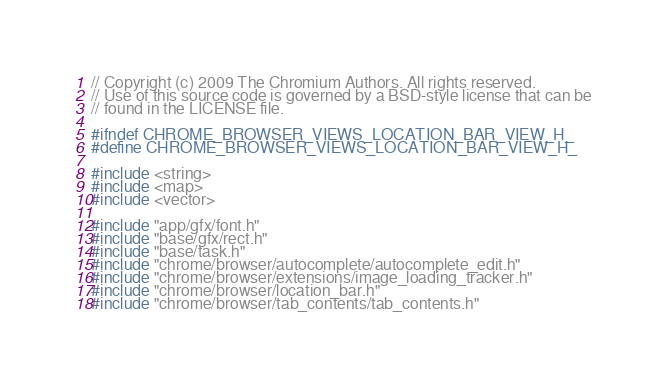Convert code to text. <code><loc_0><loc_0><loc_500><loc_500><_C_>// Copyright (c) 2009 The Chromium Authors. All rights reserved.
// Use of this source code is governed by a BSD-style license that can be
// found in the LICENSE file.

#ifndef CHROME_BROWSER_VIEWS_LOCATION_BAR_VIEW_H_
#define CHROME_BROWSER_VIEWS_LOCATION_BAR_VIEW_H_

#include <string>
#include <map>
#include <vector>

#include "app/gfx/font.h"
#include "base/gfx/rect.h"
#include "base/task.h"
#include "chrome/browser/autocomplete/autocomplete_edit.h"
#include "chrome/browser/extensions/image_loading_tracker.h"
#include "chrome/browser/location_bar.h"
#include "chrome/browser/tab_contents/tab_contents.h"</code> 